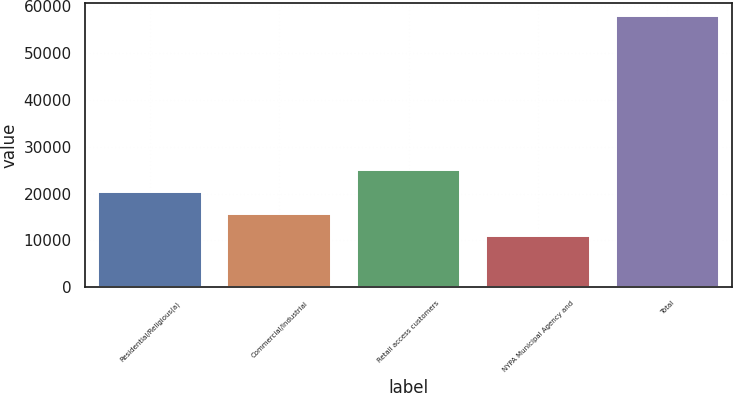Convert chart to OTSL. <chart><loc_0><loc_0><loc_500><loc_500><bar_chart><fcel>Residential/Religious(a)<fcel>Commercial/Industrial<fcel>Retail access customers<fcel>NYPA Municipal Agency and<fcel>Total<nl><fcel>20397.2<fcel>15718.6<fcel>25075.8<fcel>11040<fcel>57826<nl></chart> 